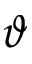Convert formula to latex. <formula><loc_0><loc_0><loc_500><loc_500>\vartheta</formula> 